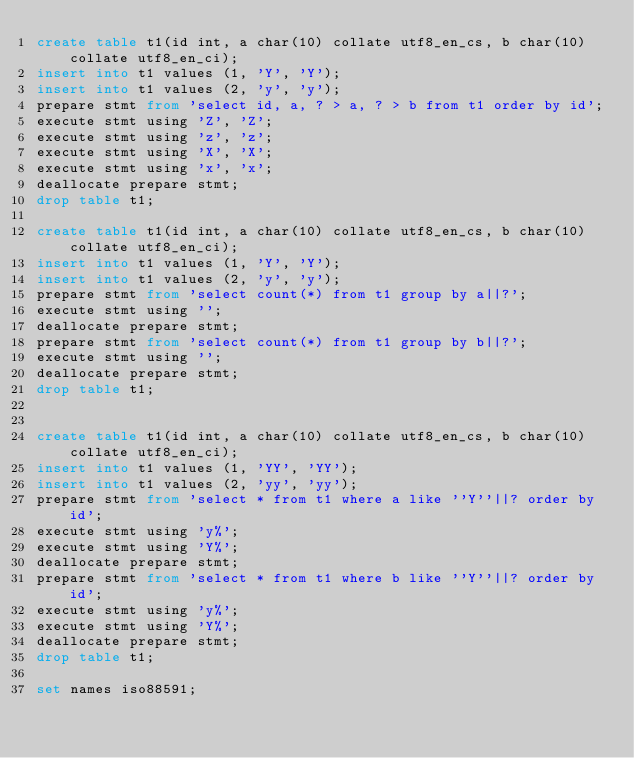Convert code to text. <code><loc_0><loc_0><loc_500><loc_500><_SQL_>create table t1(id int, a char(10) collate utf8_en_cs, b char(10) collate utf8_en_ci);
insert into t1 values (1, 'Y', 'Y');
insert into t1 values (2, 'y', 'y');
prepare stmt from 'select id, a, ? > a, ? > b from t1 order by id';
execute stmt using 'Z', 'Z';
execute stmt using 'z', 'z';
execute stmt using 'X', 'X';
execute stmt using 'x', 'x';
deallocate prepare stmt;
drop table t1;

create table t1(id int, a char(10) collate utf8_en_cs, b char(10) collate utf8_en_ci);
insert into t1 values (1, 'Y', 'Y');
insert into t1 values (2, 'y', 'y');
prepare stmt from 'select count(*) from t1 group by a||?';
execute stmt using '';
deallocate prepare stmt;
prepare stmt from 'select count(*) from t1 group by b||?';
execute stmt using '';
deallocate prepare stmt;
drop table t1;


create table t1(id int, a char(10) collate utf8_en_cs, b char(10) collate utf8_en_ci);
insert into t1 values (1, 'YY', 'YY');
insert into t1 values (2, 'yy', 'yy');
prepare stmt from 'select * from t1 where a like ''Y''||? order by id';
execute stmt using 'y%';
execute stmt using 'Y%';
deallocate prepare stmt;
prepare stmt from 'select * from t1 where b like ''Y''||? order by id';
execute stmt using 'y%';
execute stmt using 'Y%';
deallocate prepare stmt;
drop table t1;

set names iso88591;
</code> 